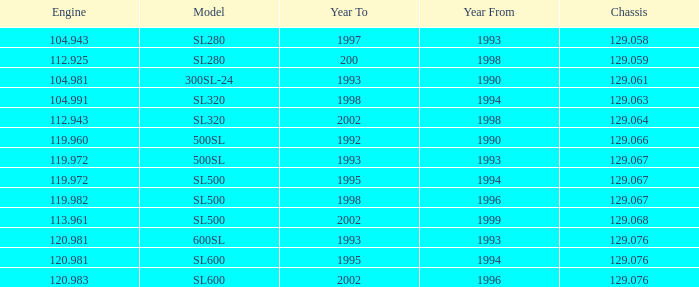Which Engine has a Model of sl500, and a Chassis smaller than 129.067? None. 